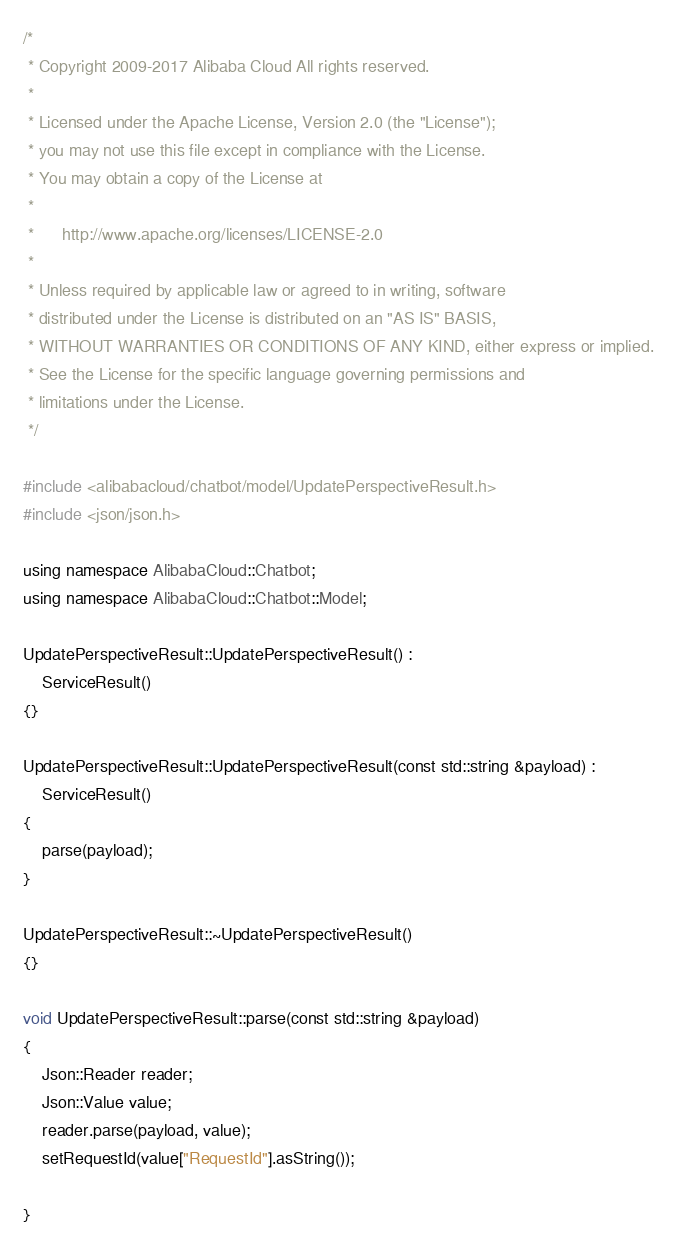Convert code to text. <code><loc_0><loc_0><loc_500><loc_500><_C++_>/*
 * Copyright 2009-2017 Alibaba Cloud All rights reserved.
 * 
 * Licensed under the Apache License, Version 2.0 (the "License");
 * you may not use this file except in compliance with the License.
 * You may obtain a copy of the License at
 * 
 *      http://www.apache.org/licenses/LICENSE-2.0
 * 
 * Unless required by applicable law or agreed to in writing, software
 * distributed under the License is distributed on an "AS IS" BASIS,
 * WITHOUT WARRANTIES OR CONDITIONS OF ANY KIND, either express or implied.
 * See the License for the specific language governing permissions and
 * limitations under the License.
 */

#include <alibabacloud/chatbot/model/UpdatePerspectiveResult.h>
#include <json/json.h>

using namespace AlibabaCloud::Chatbot;
using namespace AlibabaCloud::Chatbot::Model;

UpdatePerspectiveResult::UpdatePerspectiveResult() :
	ServiceResult()
{}

UpdatePerspectiveResult::UpdatePerspectiveResult(const std::string &payload) :
	ServiceResult()
{
	parse(payload);
}

UpdatePerspectiveResult::~UpdatePerspectiveResult()
{}

void UpdatePerspectiveResult::parse(const std::string &payload)
{
	Json::Reader reader;
	Json::Value value;
	reader.parse(payload, value);
	setRequestId(value["RequestId"].asString());

}

</code> 